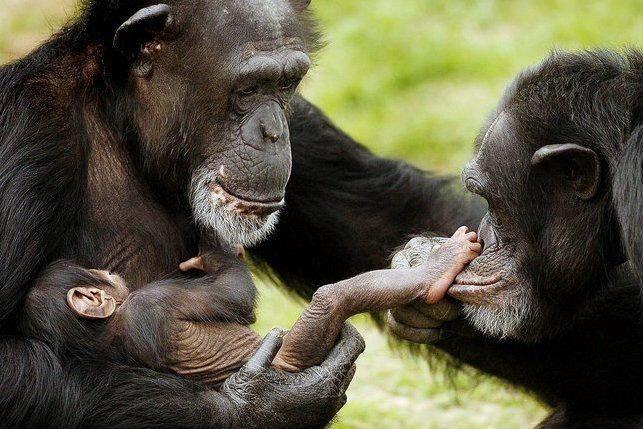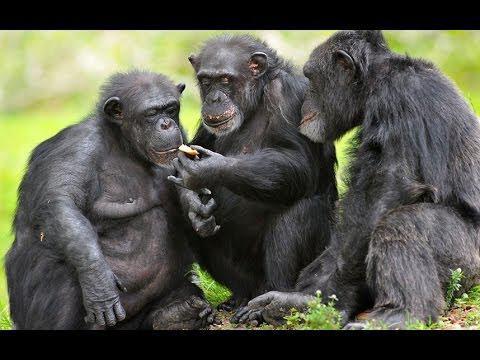The first image is the image on the left, the second image is the image on the right. For the images displayed, is the sentence "There is a chimpanzee showing something in his hand to two other chimpanzees in the right image." factually correct? Answer yes or no. Yes. The first image is the image on the left, the second image is the image on the right. For the images shown, is this caption "The lefthand image includes an adult chimp and a small juvenile chimp." true? Answer yes or no. Yes. 